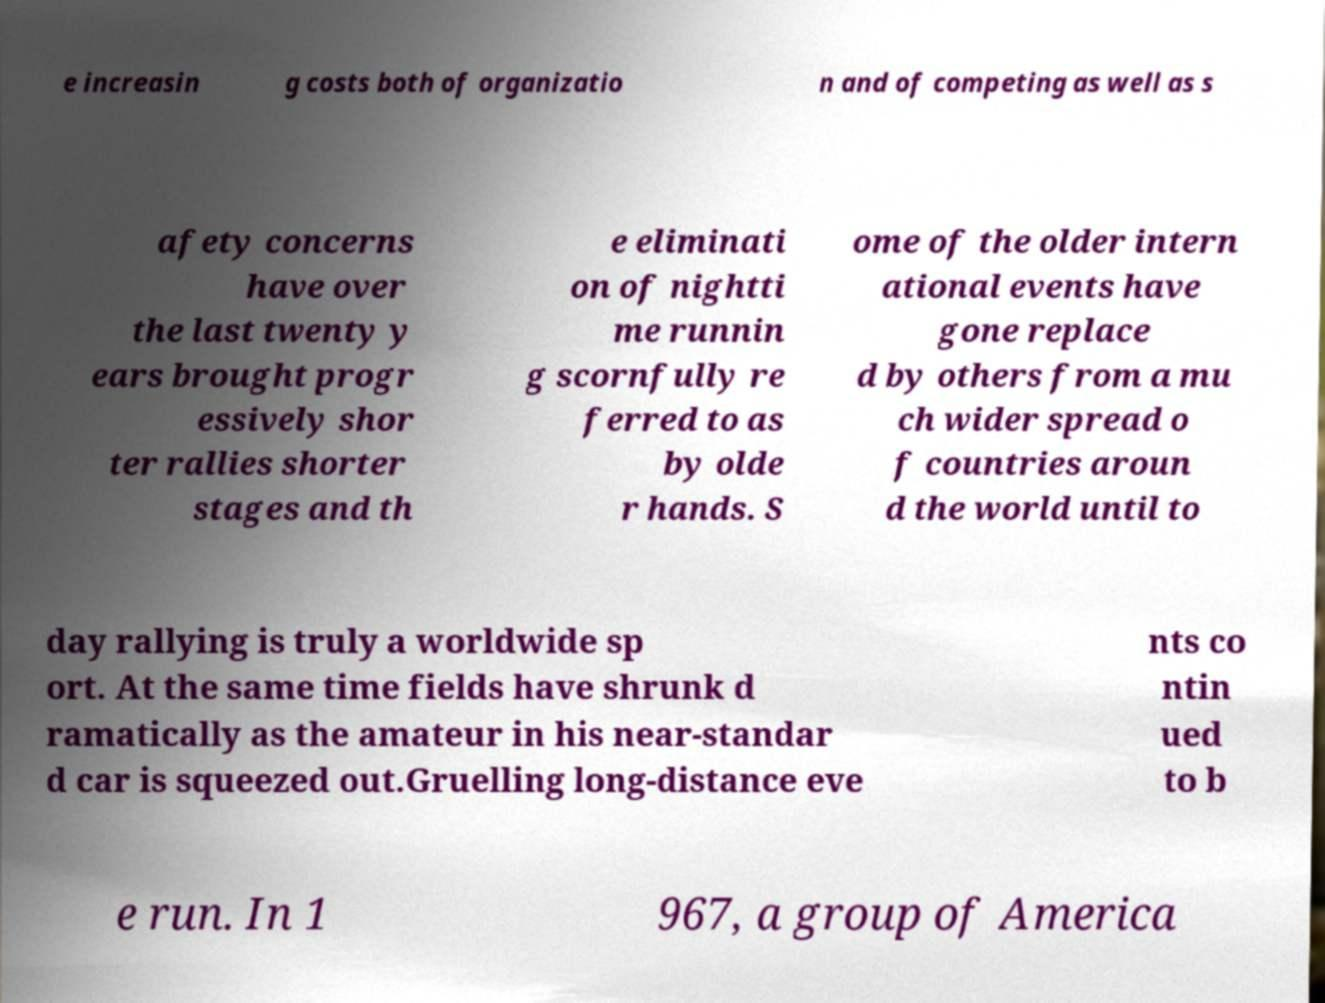Please identify and transcribe the text found in this image. e increasin g costs both of organizatio n and of competing as well as s afety concerns have over the last twenty y ears brought progr essively shor ter rallies shorter stages and th e eliminati on of nightti me runnin g scornfully re ferred to as by olde r hands. S ome of the older intern ational events have gone replace d by others from a mu ch wider spread o f countries aroun d the world until to day rallying is truly a worldwide sp ort. At the same time fields have shrunk d ramatically as the amateur in his near-standar d car is squeezed out.Gruelling long-distance eve nts co ntin ued to b e run. In 1 967, a group of America 